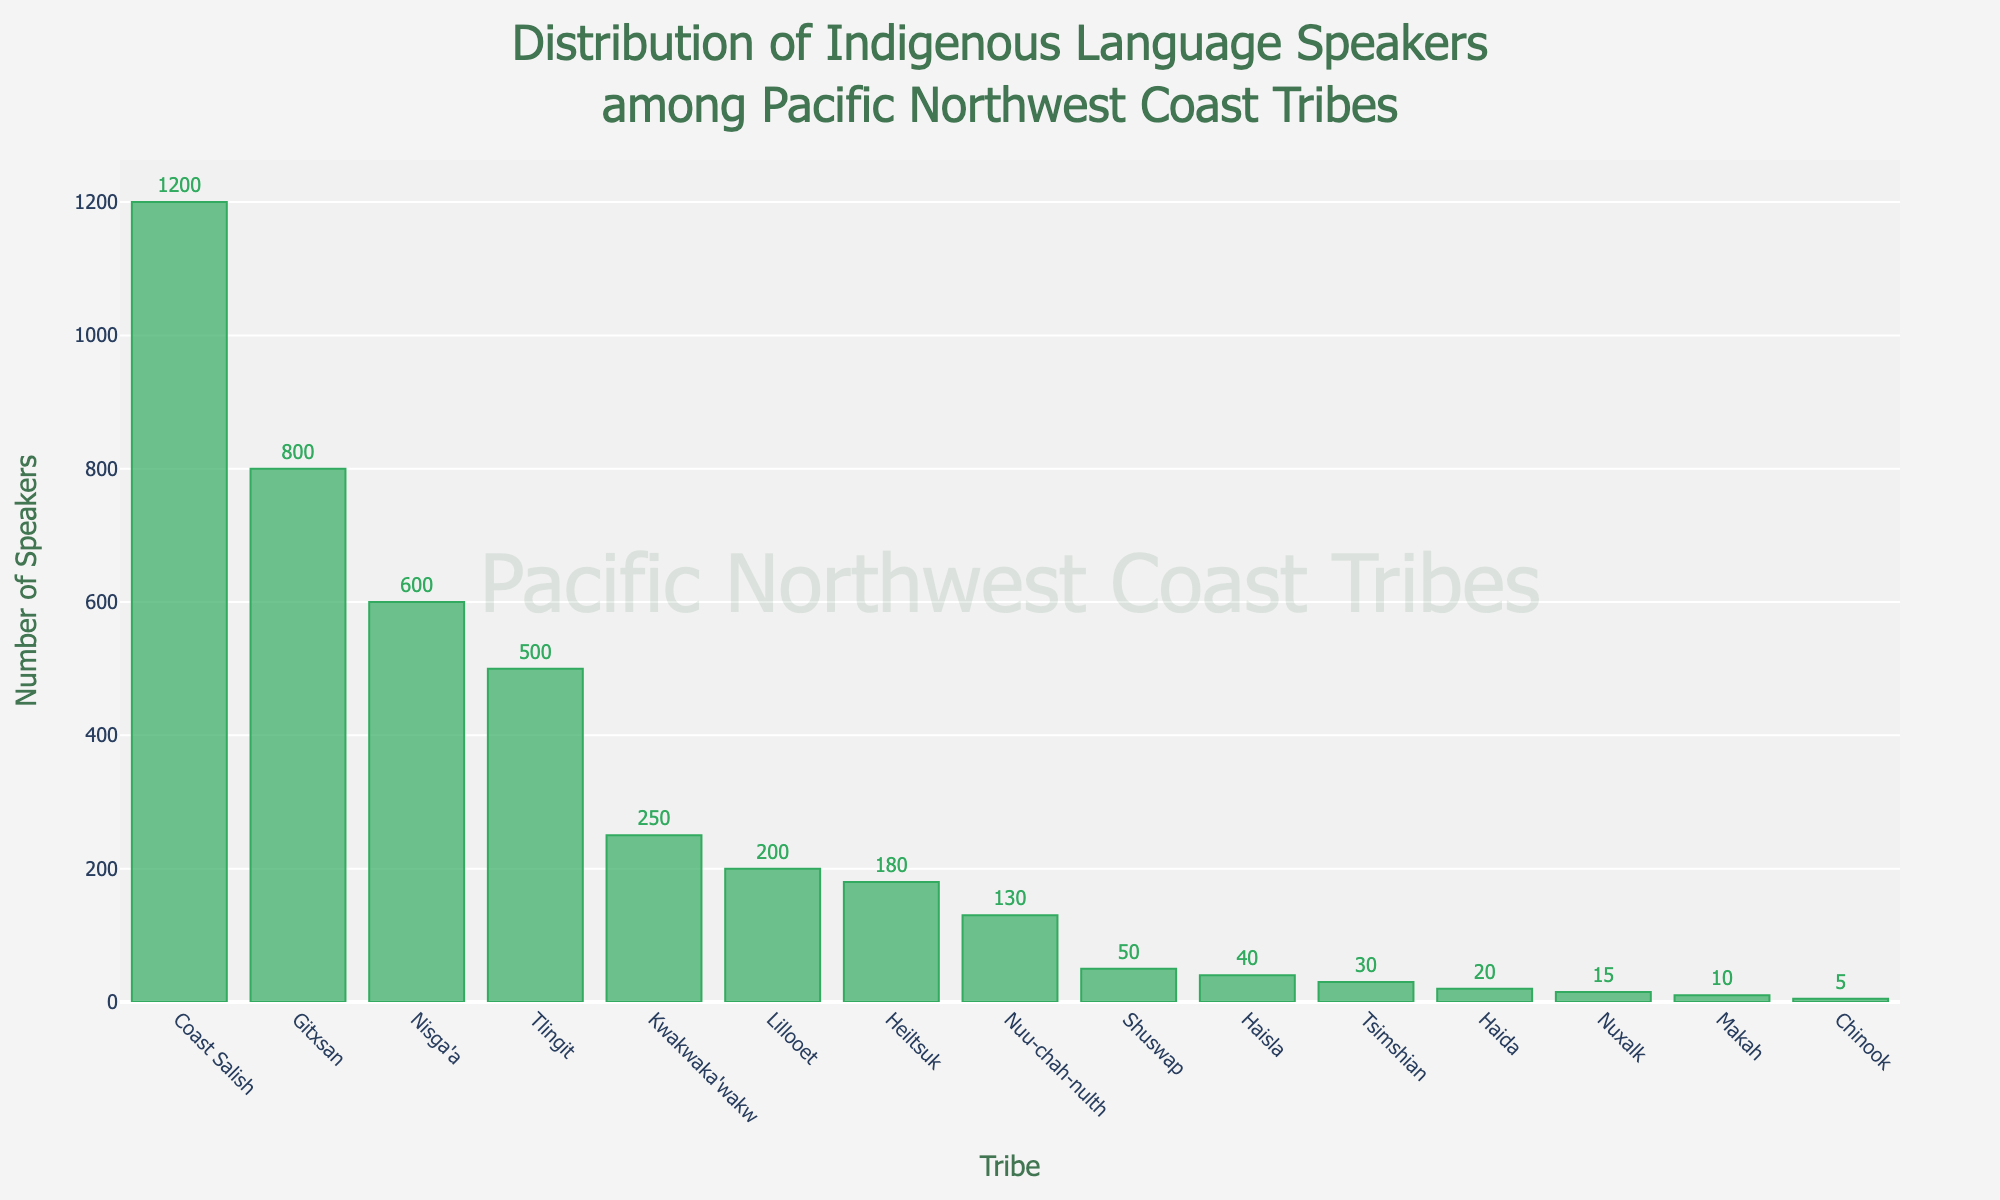Which tribe has the largest number of indigenous language speakers? The tribe with the tallest bar represents the tribe with the largest number of speakers. This bar belongs to the Coast Salish tribe.
Answer: Coast Salish Which tribe has the smallest number of indigenous language speakers? The tribe with the shortest bar represents the tribe with the smallest number of speakers. This bar belongs to the Chinook tribe.
Answer: Chinook What is the combined number of indigenous language speakers for the Gitxsan and Nisga'a tribes? The bar for Gitxsan is marked 800, and the bar for Nisga'a is marked 600. Adding these numbers together gives 800 + 600.
Answer: 1400 How many more speakers does the Coast Salish tribe have compared to the Nuu-chah-nulth tribe? The Coast Salish tribe has 1200 speakers and the Nuu-chah-nulth tribe has 130 speakers. Subtracting these values gives 1200 - 130.
Answer: 1070 What is the average number of indigenous language speakers for the Kwakwaka'wakw, Heiltsuk, and Lillooet tribes? Add the number of speakers for these tribes: 250 (Kwakwaka'wakw) + 180 (Heiltsuk) + 200 (Lillooet) = 630. Divide 630 by 3 to find the average.
Answer: 210 Which tribe has more speakers: Tlingit or Lillooet? The bar for Tlingit is marked 500, and the bar for Lillooet is marked 200. Since 500 is greater than 200, Tlingit has more speakers.
Answer: Tlingit How many tribes have fewer than 50 speakers? Identify the bars representing tribes with fewer than 50 speakers: Haida (20), Tsimshian (30), Makah (10), Chinook (5), Nuxalk (15), and Haisla (40). Count these tribes.
Answer: 6 Which tribes have between 100 and 300 speakers? Identify the bars with counts between 100 and 300: Kwakwaka'wakw (250), Nuu-chah-nulth (130), and Lillooet (200).
Answer: Kwakwaka'wakw, Nuu-chah-nulth, Lillooet What is the sum of speakers for the top 3 tribes with the most speakers? The top 3 tribes are Coast Salish (1200), Gitxsan (800), and Nisga'a (600). Add these numbers to get 1200 + 800 + 600.
Answer: 2600 What is the total number of indigenous language speakers represented by all the tribes? Add the number of speakers from all tribes: 20 (Haida) + 500 (Tlingit) + 30 (Tsimshian) + 250 (Kwakwaka'wakw) + 130 (Nuu-chah-nulth) + 1200 (Coast Salish) + 10 (Makah) + 5 (Chinook) + 180 (Heiltsuk) + 15 (Nuxalk) + 40 (Haisla) + 800 (Gitxsan) + 600 (Nisga'a) + 200 (Lillooet) + 50 (Shuswap).
Answer: 4030 